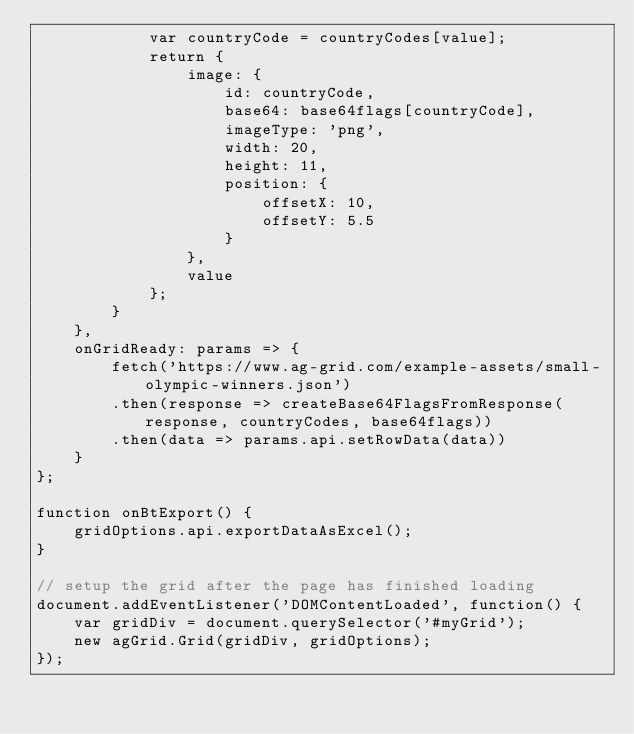<code> <loc_0><loc_0><loc_500><loc_500><_JavaScript_>            var countryCode = countryCodes[value];
            return {
                image: {
                    id: countryCode,
                    base64: base64flags[countryCode],
                    imageType: 'png',
                    width: 20,
                    height: 11,
                    position: {
                        offsetX: 10,
                        offsetY: 5.5
                    }
                },
                value
            };
        }
    },
    onGridReady: params => {
        fetch('https://www.ag-grid.com/example-assets/small-olympic-winners.json')
        .then(response => createBase64FlagsFromResponse(response, countryCodes, base64flags))
        .then(data => params.api.setRowData(data))
    }
};

function onBtExport() {
    gridOptions.api.exportDataAsExcel();
}

// setup the grid after the page has finished loading
document.addEventListener('DOMContentLoaded', function() {
    var gridDiv = document.querySelector('#myGrid');
    new agGrid.Grid(gridDiv, gridOptions);
});

</code> 